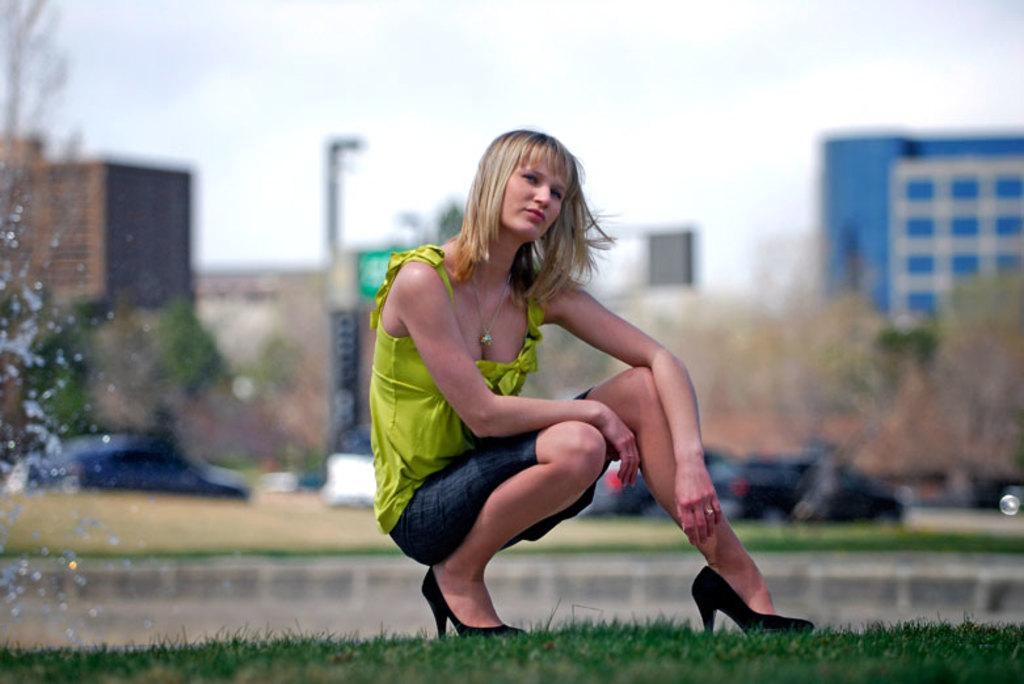How would you summarize this image in a sentence or two? In the image there is a woman in green dress sitting on the grassland and behind her there are few cars going on the road followed by buildings in the background with trees in front of it and above its sky. 